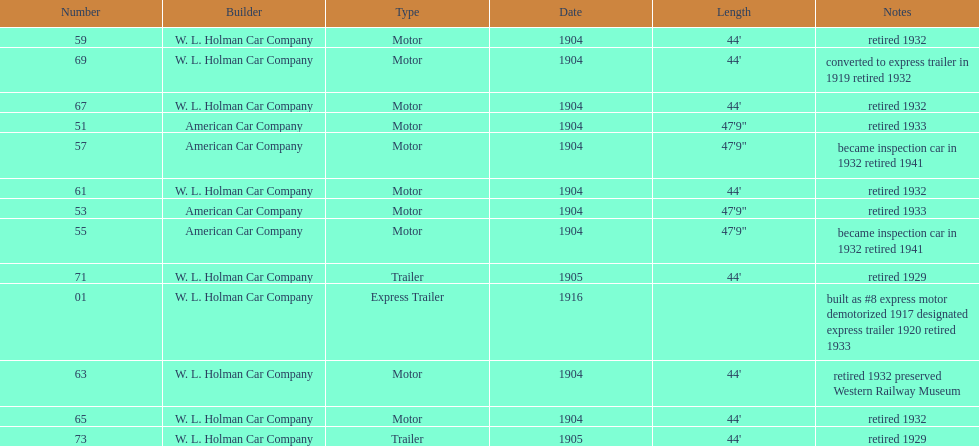In 1906, how many total rolling stock vehicles were in service? 12. 